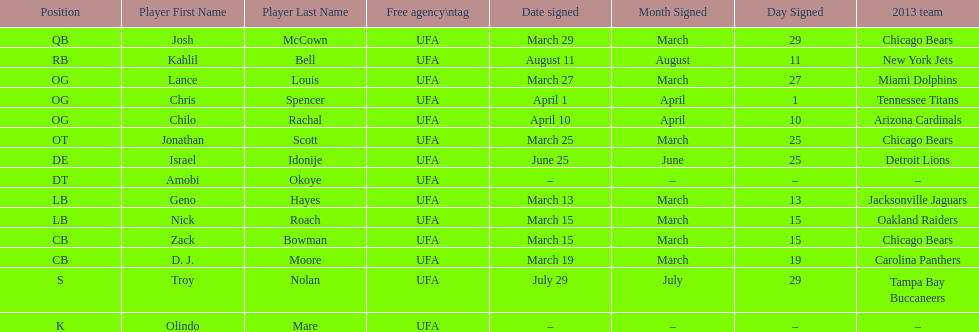Geno hayes and nick roach both played which position? LB. 